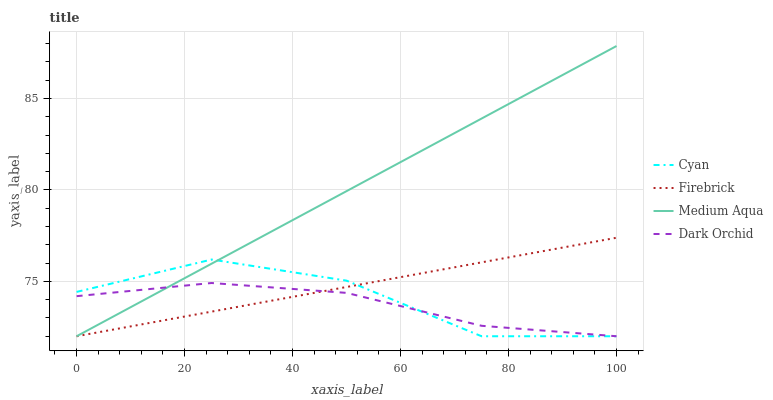Does Dark Orchid have the minimum area under the curve?
Answer yes or no. Yes. Does Medium Aqua have the maximum area under the curve?
Answer yes or no. Yes. Does Firebrick have the minimum area under the curve?
Answer yes or no. No. Does Firebrick have the maximum area under the curve?
Answer yes or no. No. Is Firebrick the smoothest?
Answer yes or no. Yes. Is Cyan the roughest?
Answer yes or no. Yes. Is Medium Aqua the smoothest?
Answer yes or no. No. Is Medium Aqua the roughest?
Answer yes or no. No. Does Cyan have the lowest value?
Answer yes or no. Yes. Does Medium Aqua have the highest value?
Answer yes or no. Yes. Does Firebrick have the highest value?
Answer yes or no. No. Does Firebrick intersect Dark Orchid?
Answer yes or no. Yes. Is Firebrick less than Dark Orchid?
Answer yes or no. No. Is Firebrick greater than Dark Orchid?
Answer yes or no. No. 